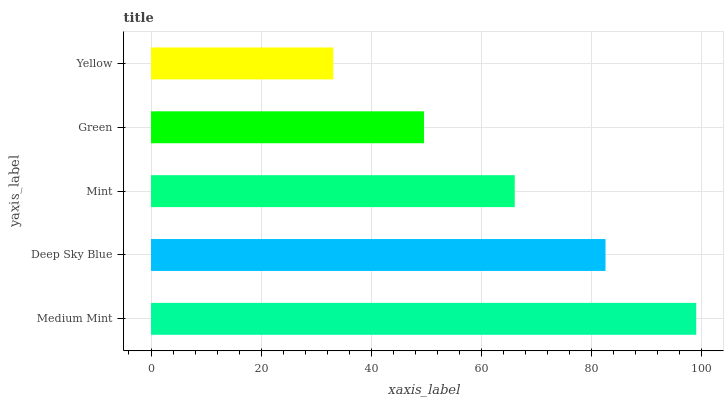Is Yellow the minimum?
Answer yes or no. Yes. Is Medium Mint the maximum?
Answer yes or no. Yes. Is Deep Sky Blue the minimum?
Answer yes or no. No. Is Deep Sky Blue the maximum?
Answer yes or no. No. Is Medium Mint greater than Deep Sky Blue?
Answer yes or no. Yes. Is Deep Sky Blue less than Medium Mint?
Answer yes or no. Yes. Is Deep Sky Blue greater than Medium Mint?
Answer yes or no. No. Is Medium Mint less than Deep Sky Blue?
Answer yes or no. No. Is Mint the high median?
Answer yes or no. Yes. Is Mint the low median?
Answer yes or no. Yes. Is Deep Sky Blue the high median?
Answer yes or no. No. Is Yellow the low median?
Answer yes or no. No. 